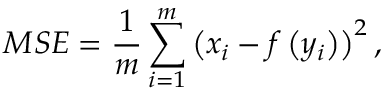Convert formula to latex. <formula><loc_0><loc_0><loc_500><loc_500>M S E = \frac { 1 } { m } \sum _ { i = 1 } ^ { m } \left ( x _ { i } - f \left ( y _ { i } \right ) \right ) ^ { 2 } ,</formula> 